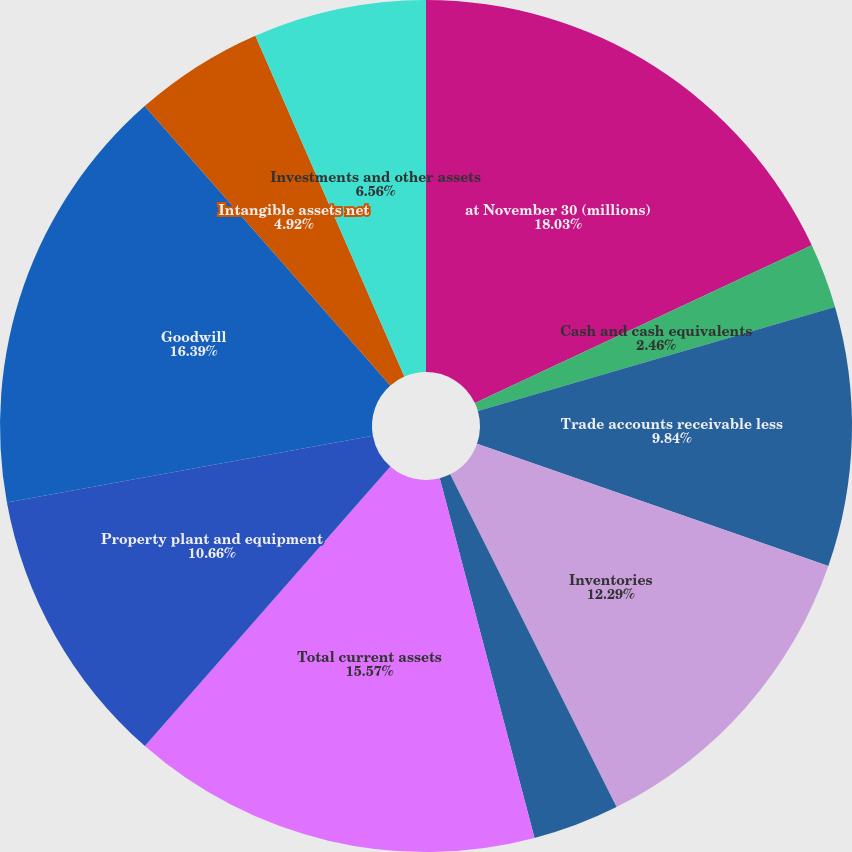Convert chart. <chart><loc_0><loc_0><loc_500><loc_500><pie_chart><fcel>at November 30 (millions)<fcel>Cash and cash equivalents<fcel>Trade accounts receivable less<fcel>Inventories<fcel>Prepaid expenses and other<fcel>Total current assets<fcel>Property plant and equipment<fcel>Goodwill<fcel>Intangible assets net<fcel>Investments and other assets<nl><fcel>18.03%<fcel>2.46%<fcel>9.84%<fcel>12.29%<fcel>3.28%<fcel>15.57%<fcel>10.66%<fcel>16.39%<fcel>4.92%<fcel>6.56%<nl></chart> 